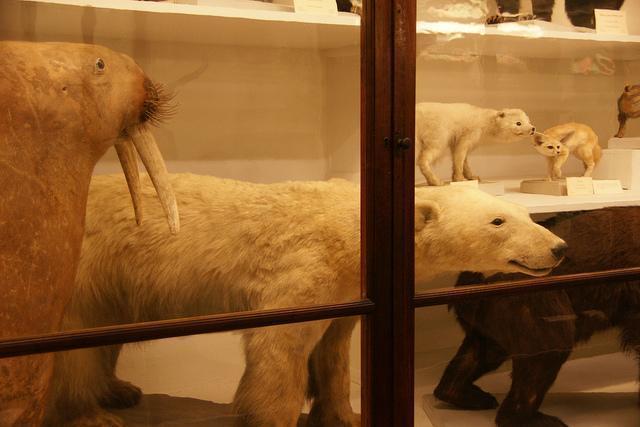How many bears can you see?
Give a very brief answer. 2. 